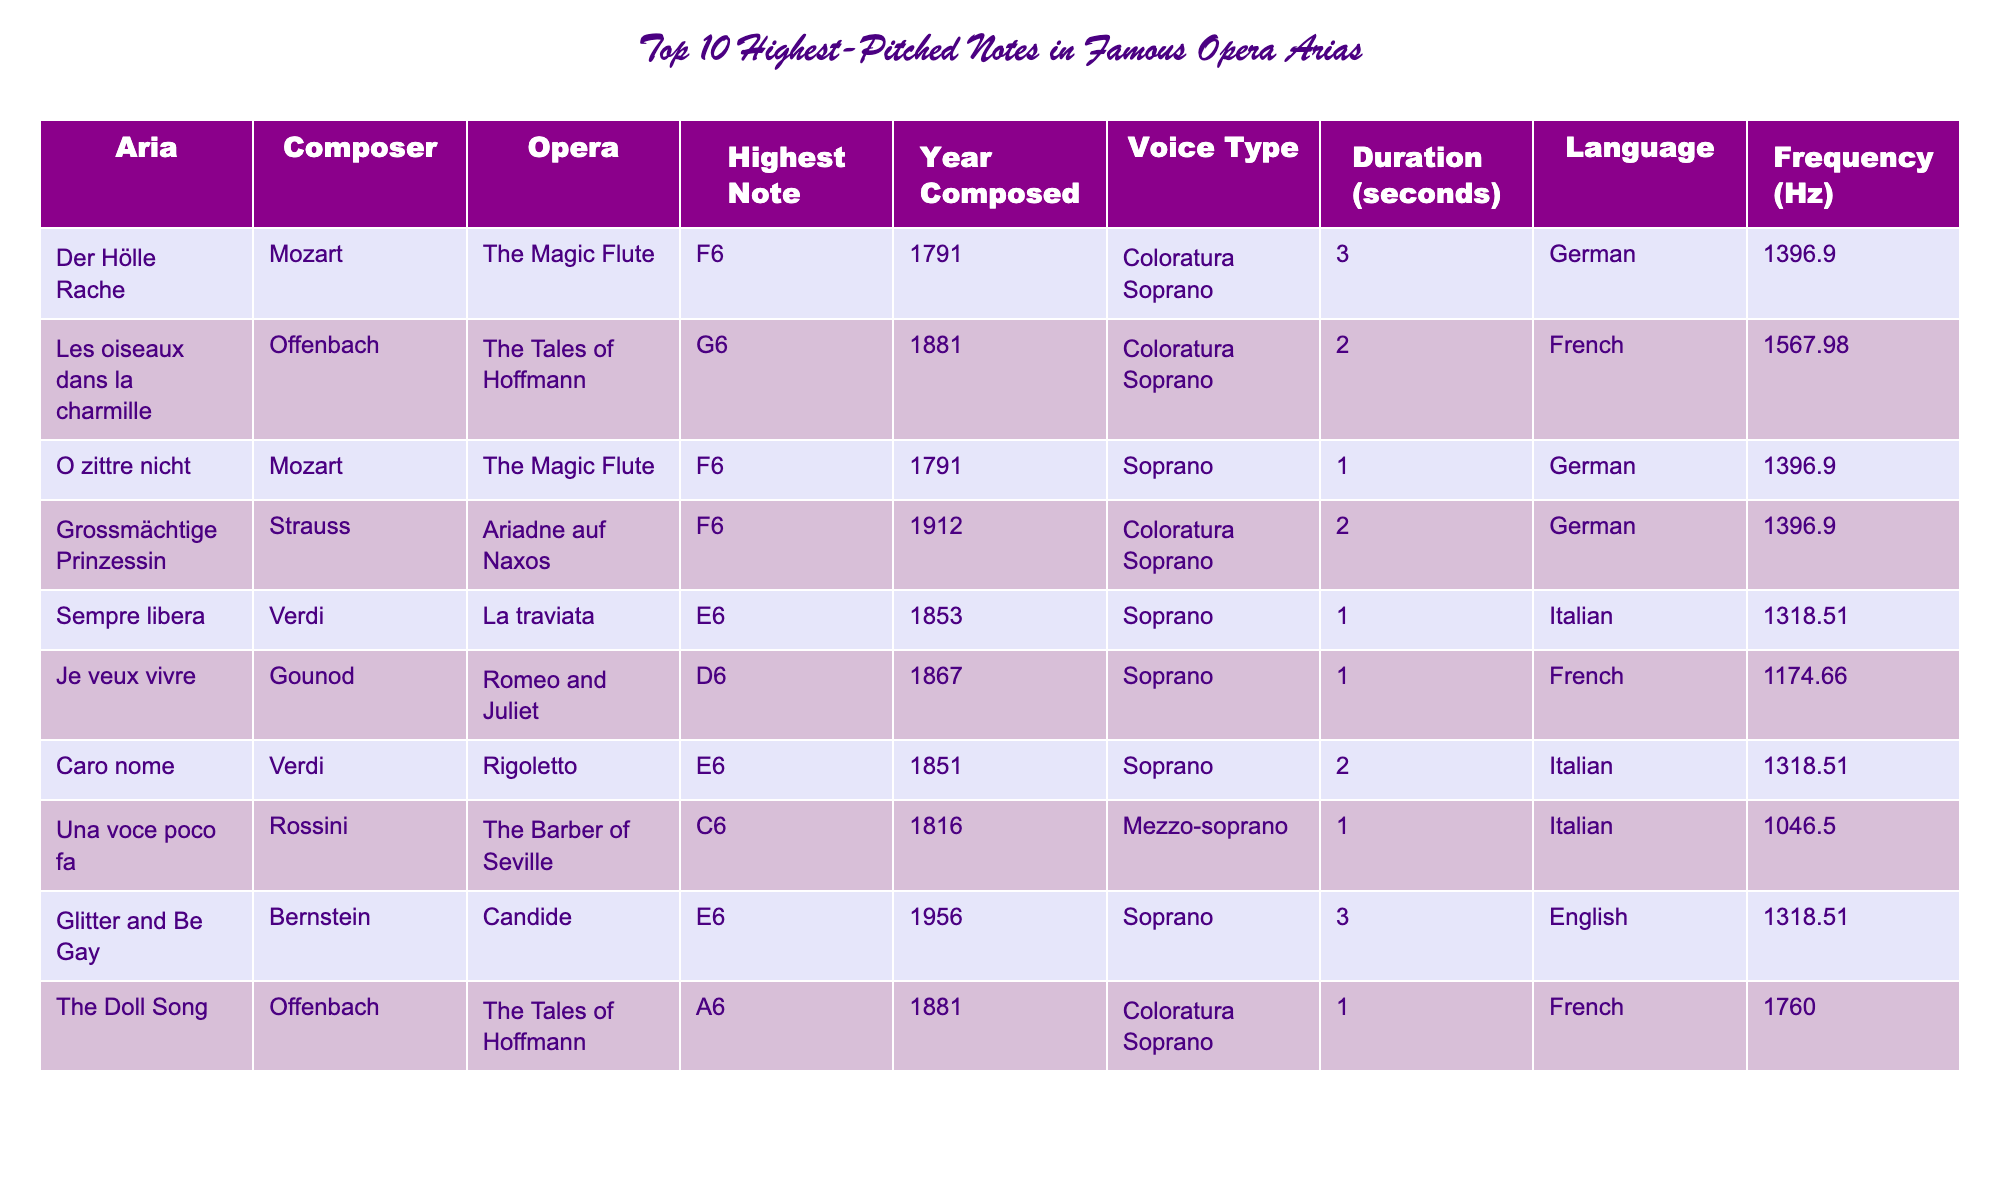What is the highest note in the table? The table lists the highest notes from various arias, and the highest note is A6 from "The Doll Song."
Answer: A6 Which aria composed first has the highest pitch? Comparing the years of composition for the two highest notes (G6 and A6), "The Doll Song" is from 1881 (A6), while the highest note F6 by Mozart is from 1791. Since A6 has a higher pitch than F6, the aria "Der Hölle Rache" is the first composed with the highest note of F6.
Answer: F6 How many notes are above E6 in this table? Analyzing the highest notes in the table, the notes above E6 are F6, G6, and A6. F6 (four occurrences), G6 (one occurrence), and A6 (one occurrence); in total, there are three listed.
Answer: 3 What is the frequency of the highest note in "Caro nome"? Looking at the row for "Caro nome," the highest note is E6, which has a frequency of 1318.51 Hz as mentioned in the table.
Answer: 1318.51 Hz Is there more than one aria composed in the same year? By checking the years in the table, the aria "Der Hölle Rache" and "O zittre nicht" both were composed in 1791. Therefore, yes, more than one aria shares this year.
Answer: Yes What is the total duration of all the arias listed? We add the durations: 3 + 2 + 1 + 2 + 1 + 1 + 2 + 1 + 3 = 16 seconds, representing the total performance time for all listed arias.
Answer: 16 seconds Which voice type has the most entries in the table? Analyzing the voice types: Coloratura Soprano appears four times, and Soprano appears four times as well, while Mezzo-soprano appears once. Thus, both Soprano and Coloratura Soprano have the most entries.
Answer: Coloratura Soprano and Soprano What is the average frequency of the highest notes? The frequencies of the highest notes are 1396.9, 1567.98, 1396.9, 1396.9, 1318.51, 1174.66, 1318.51, 1046.5, and 1760. The average is calculated as: (1396.9 + 1567.98 + 1396.9 + 1396.9 + 1318.51 + 1174.66 + 1318.51 + 1046.5 + 1760) / 9 = 1403.63 Hz.
Answer: 1403.63 Hz Which aria has the longest duration? Comparing the duration values in the table, "Der Hölle Rache" and "Glitter and Be Gay" both have a duration of 3 seconds, making them the longest.
Answer: "Der Hölle Rache" and "Glitter and Be Gay" Are there any arias in English? Checking the language column, "Glitter and Be Gay" is in English. Therefore, there is one aria in English in the list.
Answer: Yes 